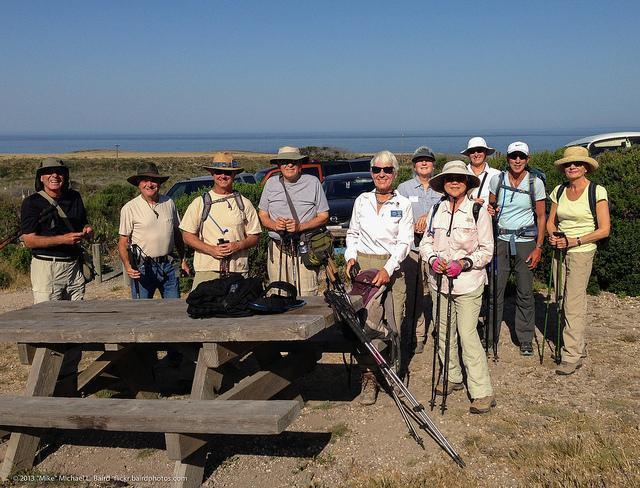What activity is this group preparing for?
Select the correct answer and articulate reasoning with the following format: 'Answer: answer
Rationale: rationale.'
Options: Running, whale watching, sailing, hiking. Answer: hiking.
Rationale: The group has hiking poles. 